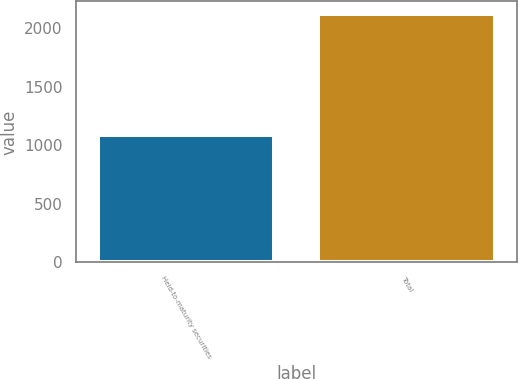<chart> <loc_0><loc_0><loc_500><loc_500><bar_chart><fcel>Held-to-maturity securities<fcel>Total<nl><fcel>1087<fcel>2122<nl></chart> 